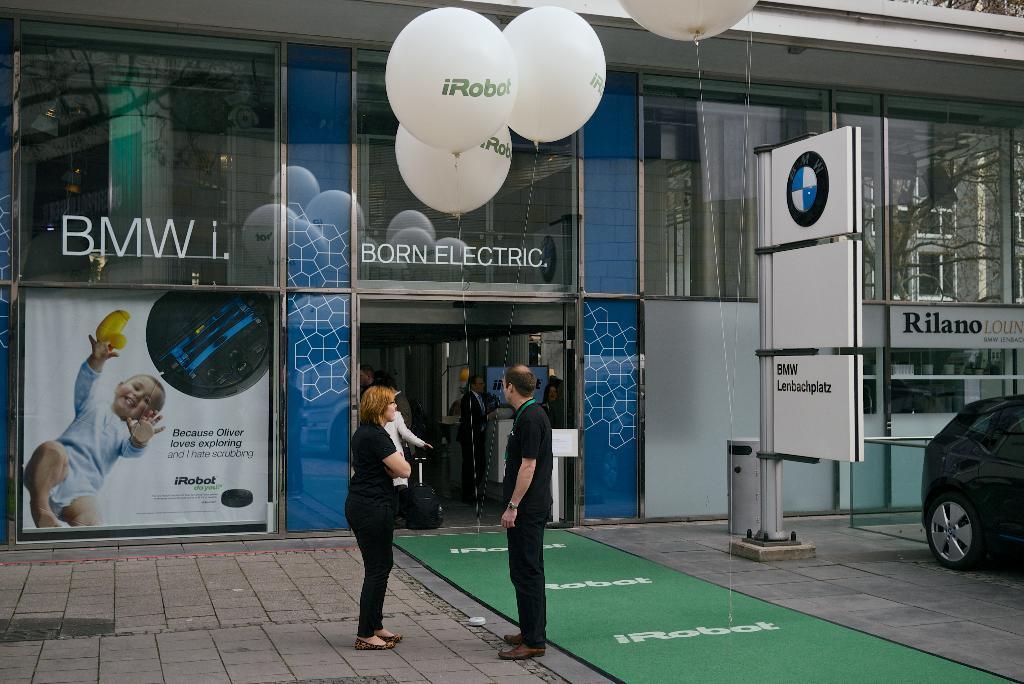How would you summarize this image in a sentence or two? In this image I can see a two persons standing and wearing black color dress. Back Side I can see a building and glass window. I can see white color balloons and green color floor mat. I can see black color car and white color sign boards. 